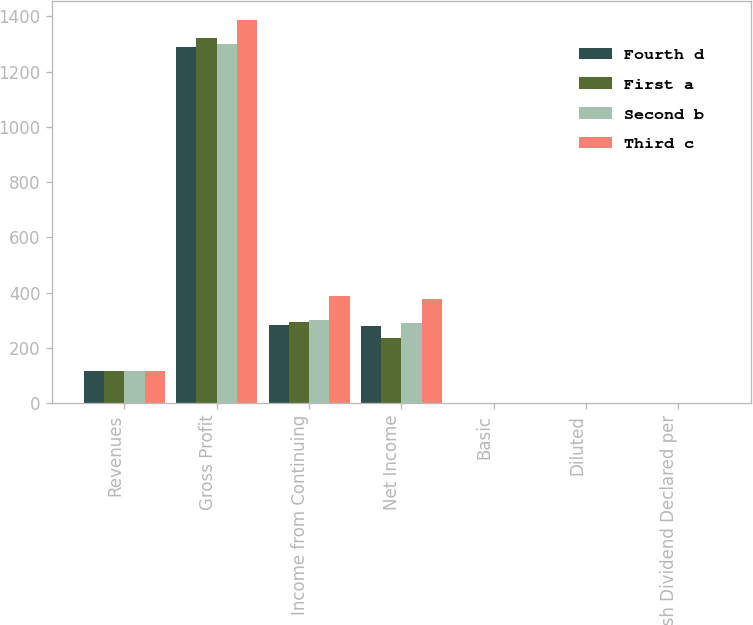<chart> <loc_0><loc_0><loc_500><loc_500><stacked_bar_chart><ecel><fcel>Revenues<fcel>Gross Profit<fcel>Income from Continuing<fcel>Net Income<fcel>Basic<fcel>Diluted<fcel>Cash Dividend Declared per<nl><fcel>Fourth d<fcel>117.44<fcel>1289.7<fcel>280.8<fcel>277.3<fcel>0.76<fcel>0.76<fcel>0.13<nl><fcel>First a<fcel>117.44<fcel>1321.3<fcel>292.4<fcel>233.8<fcel>0.8<fcel>0.79<fcel>0.13<nl><fcel>Second b<fcel>117.44<fcel>1298.4<fcel>299.4<fcel>290.4<fcel>0.83<fcel>0.82<fcel>0.13<nl><fcel>Third c<fcel>117.44<fcel>1386.1<fcel>385.8<fcel>376.4<fcel>1.08<fcel>1.07<fcel>0.15<nl></chart> 